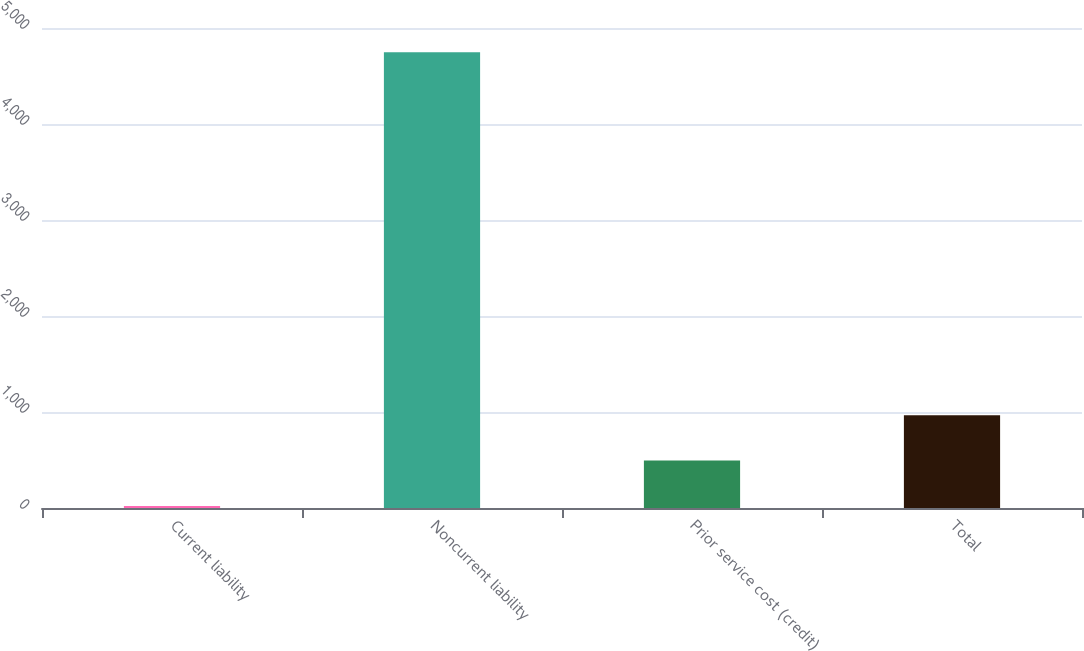Convert chart to OTSL. <chart><loc_0><loc_0><loc_500><loc_500><bar_chart><fcel>Current liability<fcel>Noncurrent liability<fcel>Prior service cost (credit)<fcel>Total<nl><fcel>21<fcel>4748<fcel>493.7<fcel>966.4<nl></chart> 